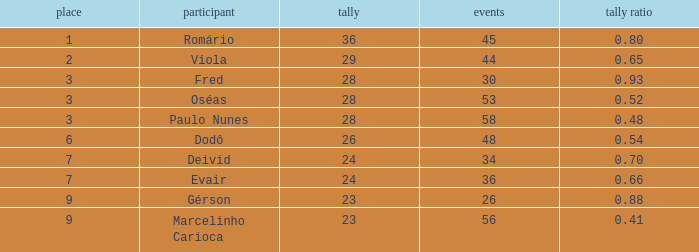What is the largest value for goals in rank over 3 with goal ration of 0.54? 26.0. 